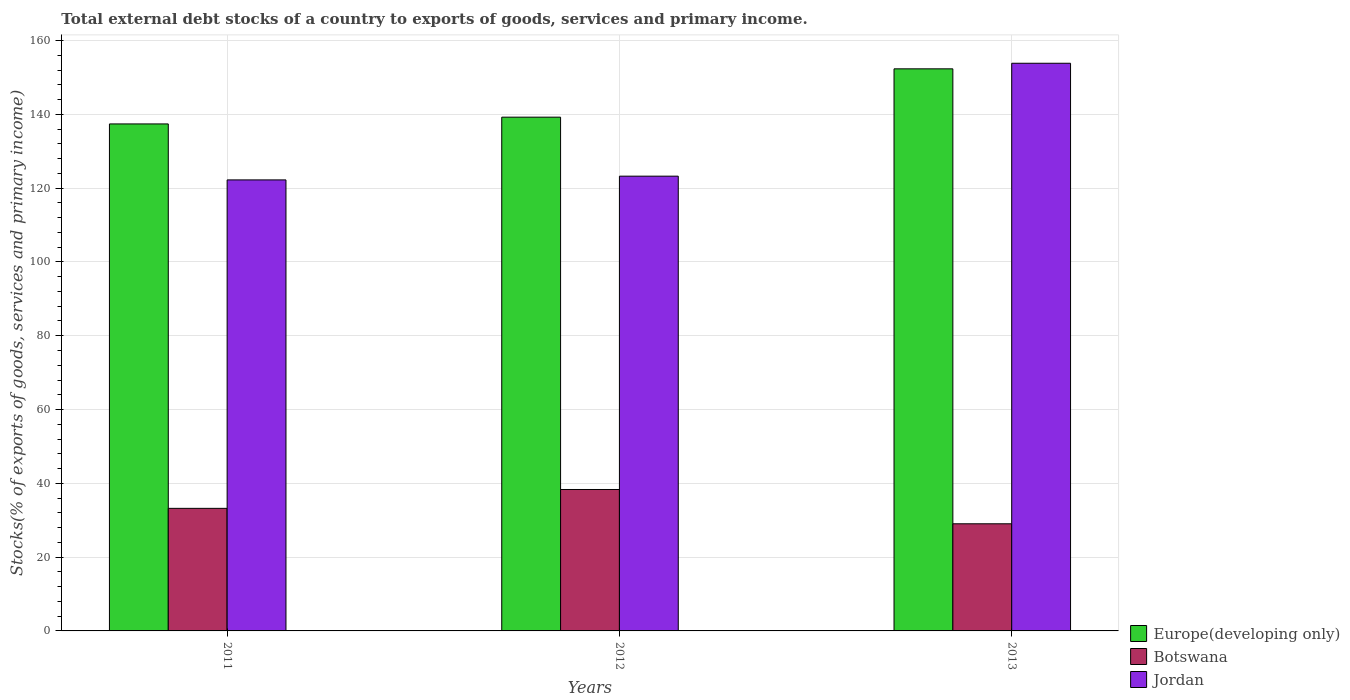In how many cases, is the number of bars for a given year not equal to the number of legend labels?
Offer a terse response. 0. What is the total debt stocks in Botswana in 2013?
Provide a succinct answer. 29.04. Across all years, what is the maximum total debt stocks in Botswana?
Make the answer very short. 38.33. Across all years, what is the minimum total debt stocks in Botswana?
Your response must be concise. 29.04. In which year was the total debt stocks in Botswana maximum?
Offer a very short reply. 2012. In which year was the total debt stocks in Botswana minimum?
Give a very brief answer. 2013. What is the total total debt stocks in Europe(developing only) in the graph?
Offer a terse response. 428.99. What is the difference between the total debt stocks in Jordan in 2012 and that in 2013?
Make the answer very short. -30.6. What is the difference between the total debt stocks in Jordan in 2011 and the total debt stocks in Botswana in 2013?
Make the answer very short. 93.2. What is the average total debt stocks in Europe(developing only) per year?
Give a very brief answer. 143. In the year 2013, what is the difference between the total debt stocks in Botswana and total debt stocks in Jordan?
Your response must be concise. -124.82. In how many years, is the total debt stocks in Jordan greater than 48 %?
Keep it short and to the point. 3. What is the ratio of the total debt stocks in Europe(developing only) in 2011 to that in 2013?
Offer a very short reply. 0.9. What is the difference between the highest and the second highest total debt stocks in Jordan?
Offer a terse response. 30.6. What is the difference between the highest and the lowest total debt stocks in Europe(developing only)?
Offer a very short reply. 14.93. In how many years, is the total debt stocks in Jordan greater than the average total debt stocks in Jordan taken over all years?
Keep it short and to the point. 1. What does the 1st bar from the left in 2011 represents?
Provide a short and direct response. Europe(developing only). What does the 3rd bar from the right in 2012 represents?
Give a very brief answer. Europe(developing only). Is it the case that in every year, the sum of the total debt stocks in Europe(developing only) and total debt stocks in Botswana is greater than the total debt stocks in Jordan?
Your response must be concise. Yes. Are all the bars in the graph horizontal?
Provide a succinct answer. No. Does the graph contain grids?
Give a very brief answer. Yes. Where does the legend appear in the graph?
Provide a short and direct response. Bottom right. How are the legend labels stacked?
Ensure brevity in your answer.  Vertical. What is the title of the graph?
Provide a succinct answer. Total external debt stocks of a country to exports of goods, services and primary income. Does "Haiti" appear as one of the legend labels in the graph?
Ensure brevity in your answer.  No. What is the label or title of the Y-axis?
Offer a terse response. Stocks(% of exports of goods, services and primary income). What is the Stocks(% of exports of goods, services and primary income) in Europe(developing only) in 2011?
Keep it short and to the point. 137.41. What is the Stocks(% of exports of goods, services and primary income) of Botswana in 2011?
Your response must be concise. 33.22. What is the Stocks(% of exports of goods, services and primary income) in Jordan in 2011?
Keep it short and to the point. 122.24. What is the Stocks(% of exports of goods, services and primary income) of Europe(developing only) in 2012?
Offer a terse response. 139.24. What is the Stocks(% of exports of goods, services and primary income) of Botswana in 2012?
Keep it short and to the point. 38.33. What is the Stocks(% of exports of goods, services and primary income) of Jordan in 2012?
Keep it short and to the point. 123.25. What is the Stocks(% of exports of goods, services and primary income) of Europe(developing only) in 2013?
Give a very brief answer. 152.34. What is the Stocks(% of exports of goods, services and primary income) of Botswana in 2013?
Your answer should be compact. 29.04. What is the Stocks(% of exports of goods, services and primary income) of Jordan in 2013?
Make the answer very short. 153.85. Across all years, what is the maximum Stocks(% of exports of goods, services and primary income) in Europe(developing only)?
Provide a succinct answer. 152.34. Across all years, what is the maximum Stocks(% of exports of goods, services and primary income) in Botswana?
Give a very brief answer. 38.33. Across all years, what is the maximum Stocks(% of exports of goods, services and primary income) in Jordan?
Offer a terse response. 153.85. Across all years, what is the minimum Stocks(% of exports of goods, services and primary income) in Europe(developing only)?
Provide a short and direct response. 137.41. Across all years, what is the minimum Stocks(% of exports of goods, services and primary income) of Botswana?
Keep it short and to the point. 29.04. Across all years, what is the minimum Stocks(% of exports of goods, services and primary income) in Jordan?
Your answer should be very brief. 122.24. What is the total Stocks(% of exports of goods, services and primary income) of Europe(developing only) in the graph?
Your answer should be very brief. 428.99. What is the total Stocks(% of exports of goods, services and primary income) of Botswana in the graph?
Your answer should be compact. 100.59. What is the total Stocks(% of exports of goods, services and primary income) of Jordan in the graph?
Your answer should be very brief. 399.35. What is the difference between the Stocks(% of exports of goods, services and primary income) in Europe(developing only) in 2011 and that in 2012?
Ensure brevity in your answer.  -1.84. What is the difference between the Stocks(% of exports of goods, services and primary income) in Botswana in 2011 and that in 2012?
Make the answer very short. -5.11. What is the difference between the Stocks(% of exports of goods, services and primary income) of Jordan in 2011 and that in 2012?
Make the answer very short. -1.01. What is the difference between the Stocks(% of exports of goods, services and primary income) of Europe(developing only) in 2011 and that in 2013?
Offer a terse response. -14.93. What is the difference between the Stocks(% of exports of goods, services and primary income) in Botswana in 2011 and that in 2013?
Your answer should be very brief. 4.18. What is the difference between the Stocks(% of exports of goods, services and primary income) in Jordan in 2011 and that in 2013?
Give a very brief answer. -31.61. What is the difference between the Stocks(% of exports of goods, services and primary income) of Europe(developing only) in 2012 and that in 2013?
Give a very brief answer. -13.1. What is the difference between the Stocks(% of exports of goods, services and primary income) of Botswana in 2012 and that in 2013?
Provide a short and direct response. 9.29. What is the difference between the Stocks(% of exports of goods, services and primary income) in Jordan in 2012 and that in 2013?
Provide a short and direct response. -30.6. What is the difference between the Stocks(% of exports of goods, services and primary income) of Europe(developing only) in 2011 and the Stocks(% of exports of goods, services and primary income) of Botswana in 2012?
Give a very brief answer. 99.08. What is the difference between the Stocks(% of exports of goods, services and primary income) of Europe(developing only) in 2011 and the Stocks(% of exports of goods, services and primary income) of Jordan in 2012?
Provide a succinct answer. 14.15. What is the difference between the Stocks(% of exports of goods, services and primary income) of Botswana in 2011 and the Stocks(% of exports of goods, services and primary income) of Jordan in 2012?
Make the answer very short. -90.04. What is the difference between the Stocks(% of exports of goods, services and primary income) of Europe(developing only) in 2011 and the Stocks(% of exports of goods, services and primary income) of Botswana in 2013?
Ensure brevity in your answer.  108.37. What is the difference between the Stocks(% of exports of goods, services and primary income) in Europe(developing only) in 2011 and the Stocks(% of exports of goods, services and primary income) in Jordan in 2013?
Keep it short and to the point. -16.45. What is the difference between the Stocks(% of exports of goods, services and primary income) in Botswana in 2011 and the Stocks(% of exports of goods, services and primary income) in Jordan in 2013?
Offer a terse response. -120.63. What is the difference between the Stocks(% of exports of goods, services and primary income) of Europe(developing only) in 2012 and the Stocks(% of exports of goods, services and primary income) of Botswana in 2013?
Keep it short and to the point. 110.21. What is the difference between the Stocks(% of exports of goods, services and primary income) in Europe(developing only) in 2012 and the Stocks(% of exports of goods, services and primary income) in Jordan in 2013?
Ensure brevity in your answer.  -14.61. What is the difference between the Stocks(% of exports of goods, services and primary income) in Botswana in 2012 and the Stocks(% of exports of goods, services and primary income) in Jordan in 2013?
Offer a terse response. -115.52. What is the average Stocks(% of exports of goods, services and primary income) in Europe(developing only) per year?
Provide a succinct answer. 143. What is the average Stocks(% of exports of goods, services and primary income) of Botswana per year?
Your answer should be very brief. 33.53. What is the average Stocks(% of exports of goods, services and primary income) of Jordan per year?
Keep it short and to the point. 133.12. In the year 2011, what is the difference between the Stocks(% of exports of goods, services and primary income) in Europe(developing only) and Stocks(% of exports of goods, services and primary income) in Botswana?
Offer a terse response. 104.19. In the year 2011, what is the difference between the Stocks(% of exports of goods, services and primary income) of Europe(developing only) and Stocks(% of exports of goods, services and primary income) of Jordan?
Your answer should be compact. 15.17. In the year 2011, what is the difference between the Stocks(% of exports of goods, services and primary income) in Botswana and Stocks(% of exports of goods, services and primary income) in Jordan?
Provide a short and direct response. -89.02. In the year 2012, what is the difference between the Stocks(% of exports of goods, services and primary income) of Europe(developing only) and Stocks(% of exports of goods, services and primary income) of Botswana?
Provide a succinct answer. 100.91. In the year 2012, what is the difference between the Stocks(% of exports of goods, services and primary income) in Europe(developing only) and Stocks(% of exports of goods, services and primary income) in Jordan?
Your answer should be compact. 15.99. In the year 2012, what is the difference between the Stocks(% of exports of goods, services and primary income) in Botswana and Stocks(% of exports of goods, services and primary income) in Jordan?
Make the answer very short. -84.92. In the year 2013, what is the difference between the Stocks(% of exports of goods, services and primary income) in Europe(developing only) and Stocks(% of exports of goods, services and primary income) in Botswana?
Keep it short and to the point. 123.3. In the year 2013, what is the difference between the Stocks(% of exports of goods, services and primary income) in Europe(developing only) and Stocks(% of exports of goods, services and primary income) in Jordan?
Make the answer very short. -1.51. In the year 2013, what is the difference between the Stocks(% of exports of goods, services and primary income) of Botswana and Stocks(% of exports of goods, services and primary income) of Jordan?
Make the answer very short. -124.82. What is the ratio of the Stocks(% of exports of goods, services and primary income) in Europe(developing only) in 2011 to that in 2012?
Your answer should be compact. 0.99. What is the ratio of the Stocks(% of exports of goods, services and primary income) in Botswana in 2011 to that in 2012?
Ensure brevity in your answer.  0.87. What is the ratio of the Stocks(% of exports of goods, services and primary income) in Europe(developing only) in 2011 to that in 2013?
Keep it short and to the point. 0.9. What is the ratio of the Stocks(% of exports of goods, services and primary income) in Botswana in 2011 to that in 2013?
Offer a terse response. 1.14. What is the ratio of the Stocks(% of exports of goods, services and primary income) in Jordan in 2011 to that in 2013?
Offer a terse response. 0.79. What is the ratio of the Stocks(% of exports of goods, services and primary income) in Europe(developing only) in 2012 to that in 2013?
Provide a succinct answer. 0.91. What is the ratio of the Stocks(% of exports of goods, services and primary income) in Botswana in 2012 to that in 2013?
Keep it short and to the point. 1.32. What is the ratio of the Stocks(% of exports of goods, services and primary income) in Jordan in 2012 to that in 2013?
Provide a short and direct response. 0.8. What is the difference between the highest and the second highest Stocks(% of exports of goods, services and primary income) of Europe(developing only)?
Your answer should be compact. 13.1. What is the difference between the highest and the second highest Stocks(% of exports of goods, services and primary income) in Botswana?
Ensure brevity in your answer.  5.11. What is the difference between the highest and the second highest Stocks(% of exports of goods, services and primary income) in Jordan?
Offer a terse response. 30.6. What is the difference between the highest and the lowest Stocks(% of exports of goods, services and primary income) in Europe(developing only)?
Ensure brevity in your answer.  14.93. What is the difference between the highest and the lowest Stocks(% of exports of goods, services and primary income) in Botswana?
Provide a succinct answer. 9.29. What is the difference between the highest and the lowest Stocks(% of exports of goods, services and primary income) of Jordan?
Ensure brevity in your answer.  31.61. 